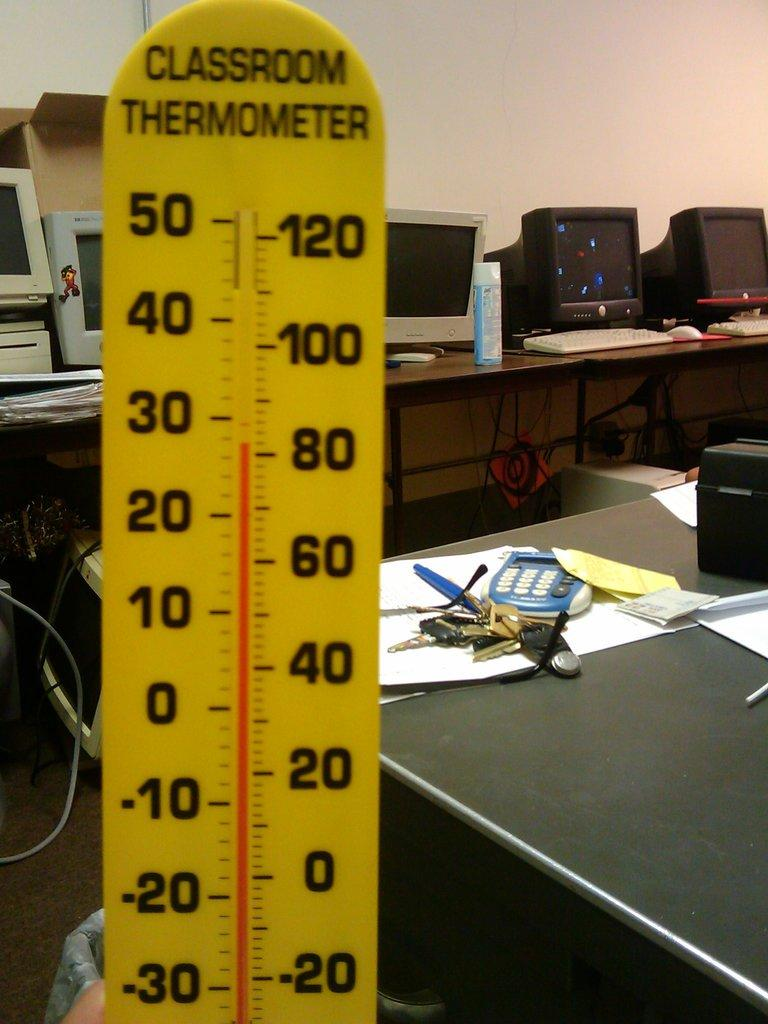<image>
Describe the image concisely. a classroom thermometer that has many numbers on it 